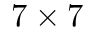Convert formula to latex. <formula><loc_0><loc_0><loc_500><loc_500>7 \times 7</formula> 